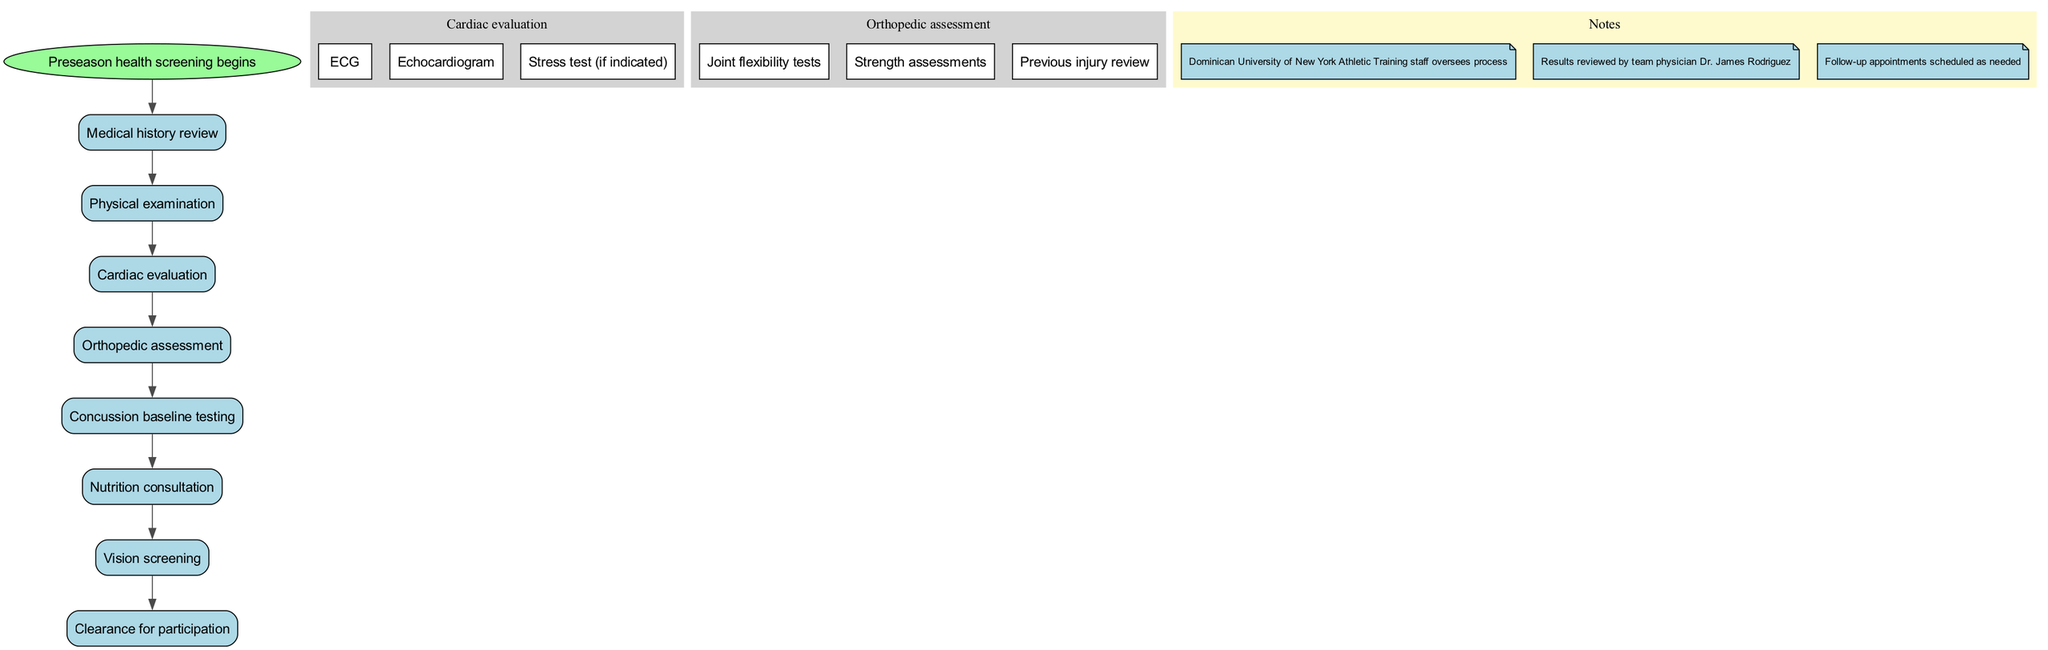What is the first step in the preseason health screening process? The diagram indicates that the first step is labeled "Preseason health screening begins," which leads to "Medical history review."
Answer: Medical history review How many total nodes are present in the diagram? The total nodes listed are 8, including the start node. This includes the main processes and subprocesses outlined in the diagram.
Answer: 8 What follows the "Physical examination" in the process? According to the diagram, the node that follows "Physical examination" is "Cardiac evaluation," indicating the flow of the process.
Answer: Cardiac evaluation Which step includes joint flexibility tests? The subprocess named "Orthopedic assessment" contains "Joint flexibility tests" as one of its components, indicating its focus on assessing physical capabilities.
Answer: Orthopedic assessment What is the last step listed in the screening process? The last step in the series of evaluations, as indicated in the diagram, is "Clearance for participation," signifying the completion of the screening.
Answer: Clearance for participation What type of evaluation is conducted before "Nutrition consultation"? The diagram shows that "Concussion baseline testing" is conducted before the "Nutrition consultation," outlining the sequence of procedures.
Answer: Concussion baseline testing Who oversees the preseason health screening process? The notes section of the diagram specifically states that the Dominican University of New York Athletic Training staff oversees the entire process.
Answer: Athletic Training staff How many subprocesses are included under "Cardiac evaluation"? Under "Cardiac evaluation," there are three subprocesses listed: ECG, Echocardiogram, and Stress test (if indicated), which collectively detail the assessments performed.
Answer: 3 